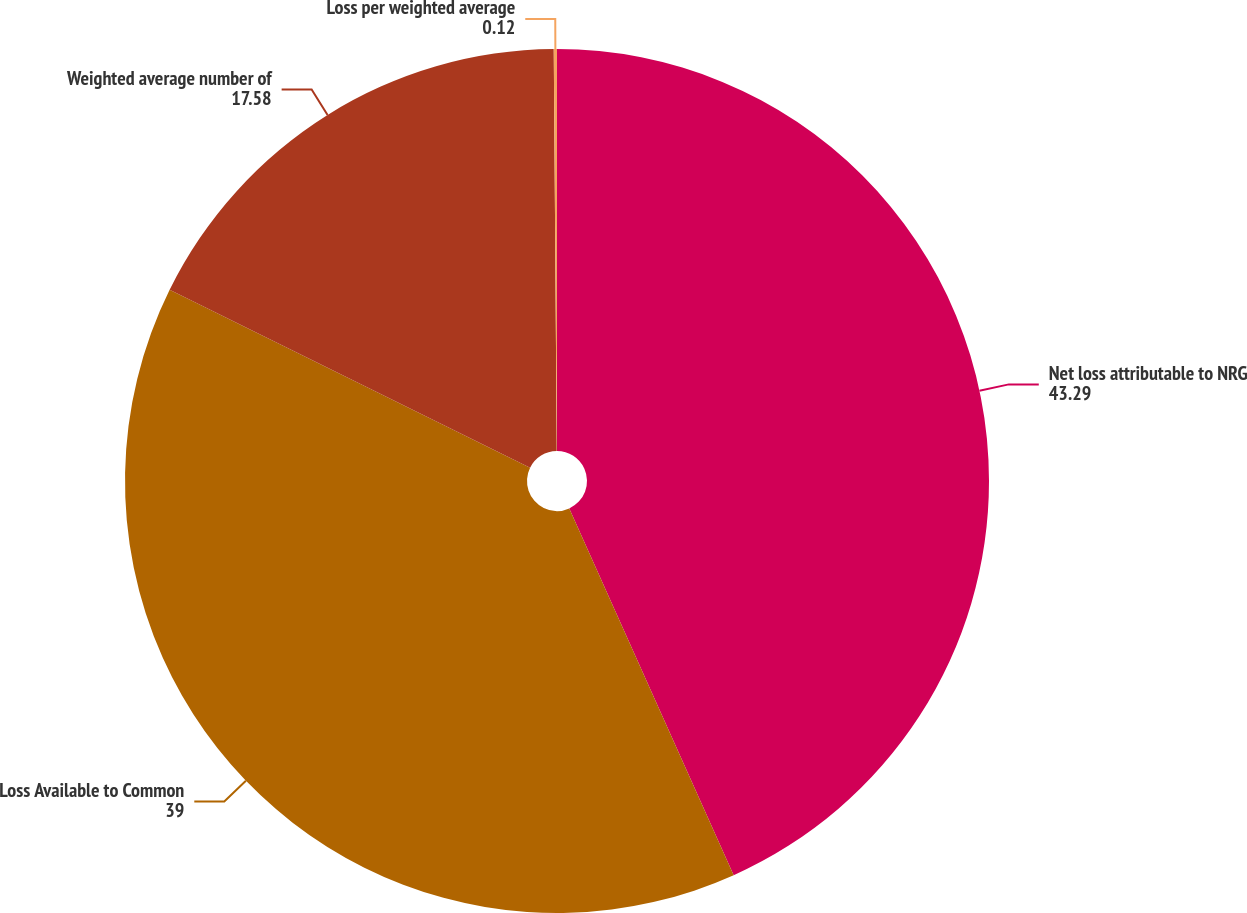Convert chart. <chart><loc_0><loc_0><loc_500><loc_500><pie_chart><fcel>Net loss attributable to NRG<fcel>Loss Available to Common<fcel>Weighted average number of<fcel>Loss per weighted average<nl><fcel>43.29%<fcel>39.0%<fcel>17.58%<fcel>0.12%<nl></chart> 